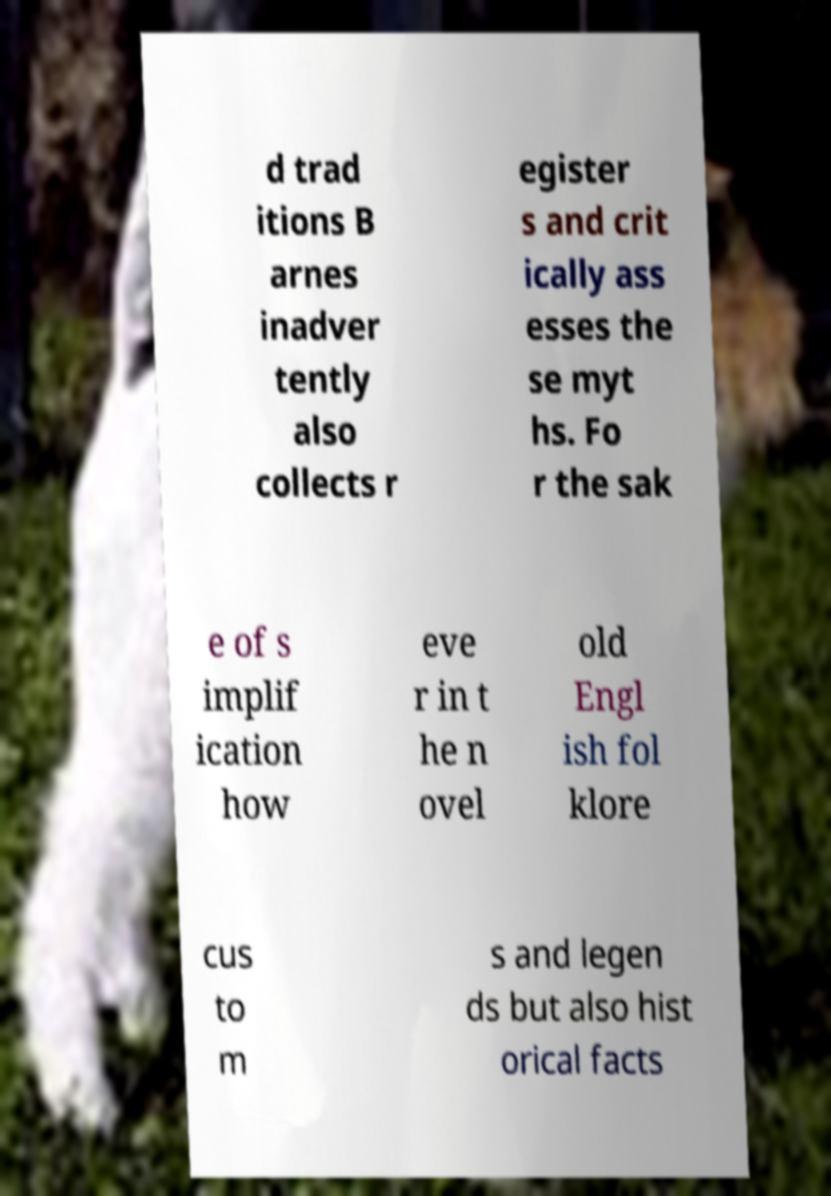What messages or text are displayed in this image? I need them in a readable, typed format. d trad itions B arnes inadver tently also collects r egister s and crit ically ass esses the se myt hs. Fo r the sak e of s implif ication how eve r in t he n ovel old Engl ish fol klore cus to m s and legen ds but also hist orical facts 